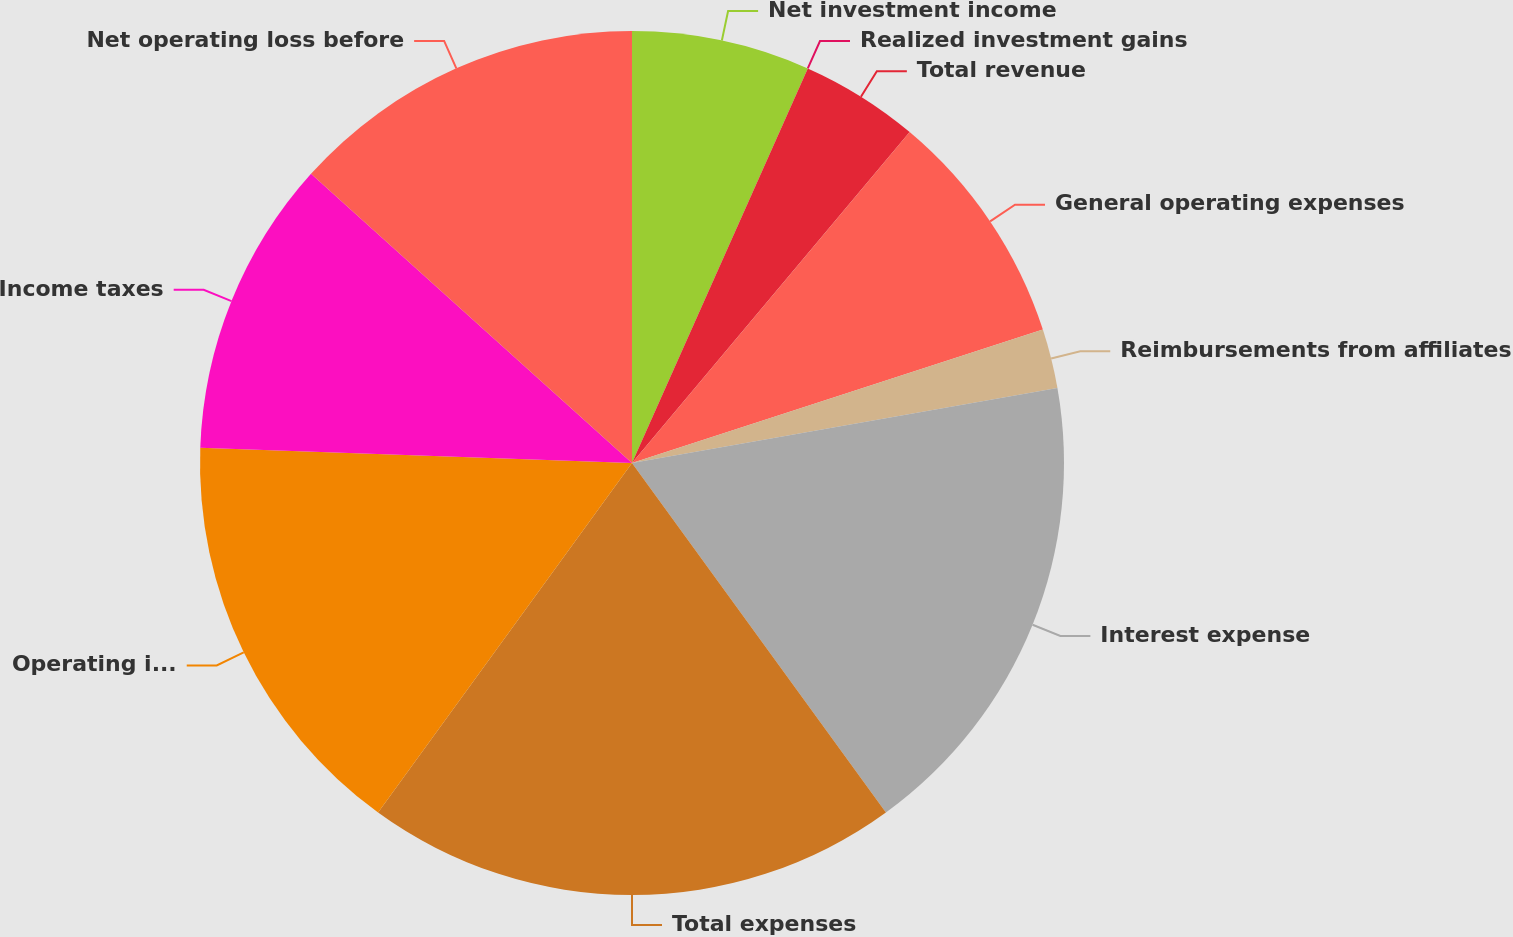Convert chart. <chart><loc_0><loc_0><loc_500><loc_500><pie_chart><fcel>Net investment income<fcel>Realized investment gains<fcel>Total revenue<fcel>General operating expenses<fcel>Reimbursements from affiliates<fcel>Interest expense<fcel>Total expenses<fcel>Operating income (loss) before<fcel>Income taxes<fcel>Net operating loss before<nl><fcel>6.67%<fcel>0.0%<fcel>4.44%<fcel>8.89%<fcel>2.22%<fcel>17.78%<fcel>20.0%<fcel>15.56%<fcel>11.11%<fcel>13.33%<nl></chart> 